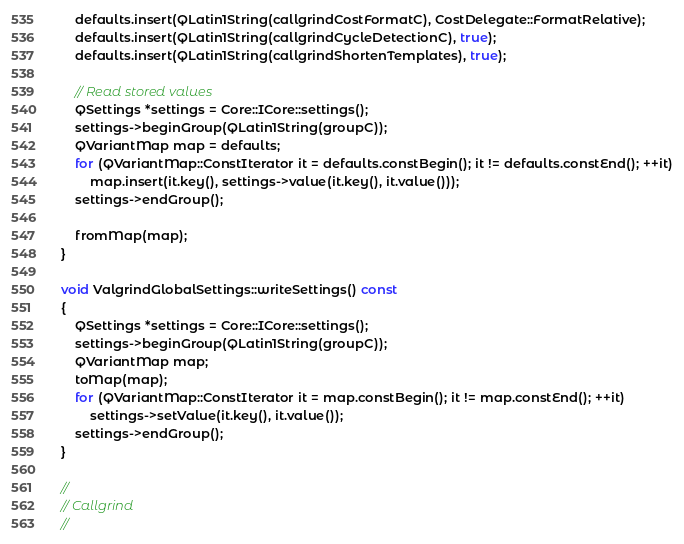Convert code to text. <code><loc_0><loc_0><loc_500><loc_500><_C++_>
    defaults.insert(QLatin1String(callgrindCostFormatC), CostDelegate::FormatRelative);
    defaults.insert(QLatin1String(callgrindCycleDetectionC), true);
    defaults.insert(QLatin1String(callgrindShortenTemplates), true);

    // Read stored values
    QSettings *settings = Core::ICore::settings();
    settings->beginGroup(QLatin1String(groupC));
    QVariantMap map = defaults;
    for (QVariantMap::ConstIterator it = defaults.constBegin(); it != defaults.constEnd(); ++it)
        map.insert(it.key(), settings->value(it.key(), it.value()));
    settings->endGroup();

    fromMap(map);
}

void ValgrindGlobalSettings::writeSettings() const
{
    QSettings *settings = Core::ICore::settings();
    settings->beginGroup(QLatin1String(groupC));
    QVariantMap map;
    toMap(map);
    for (QVariantMap::ConstIterator it = map.constBegin(); it != map.constEnd(); ++it)
        settings->setValue(it.key(), it.value());
    settings->endGroup();
}

//
// Callgrind
//</code> 